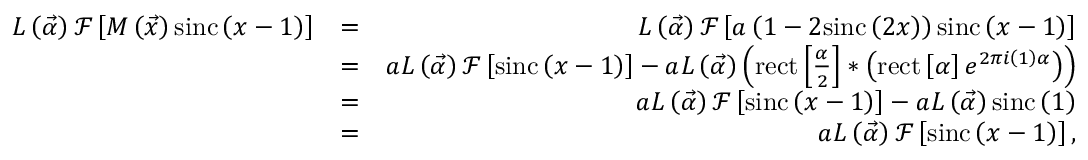<formula> <loc_0><loc_0><loc_500><loc_500>\begin{array} { r l r } { L \left ( \vec { \alpha } \right ) \mathcal { F } \left [ M \left ( \vec { x } \right ) \sin c \left ( x - 1 \right ) \right ] } & { = } & { L \left ( \vec { \alpha } \right ) \mathcal { F } \left [ a \left ( 1 - 2 \sin c \left ( 2 x \right ) \right ) \sin c \left ( x - 1 \right ) \right ] } \\ & { = } & { a L \left ( \vec { \alpha } \right ) \mathcal { F } \left [ \sin c \left ( x - 1 \right ) \right ] - a L \left ( \vec { \alpha } \right ) \left ( r e c t \left [ \frac { \alpha } { 2 } \right ] \ast \left ( r e c t \left [ \alpha \right ] e ^ { 2 \pi i \left ( 1 \right ) \alpha } \right ) \right ) } \\ & { = } & { a L \left ( \vec { \alpha } \right ) \mathcal { F } \left [ \sin c \left ( x - 1 \right ) \right ] - a L \left ( \vec { \alpha } \right ) \sin c \left ( 1 \right ) } \\ & { = } & { a L \left ( \vec { \alpha } \right ) \mathcal { F } \left [ \sin c \left ( x - 1 \right ) \right ] , } \end{array}</formula> 